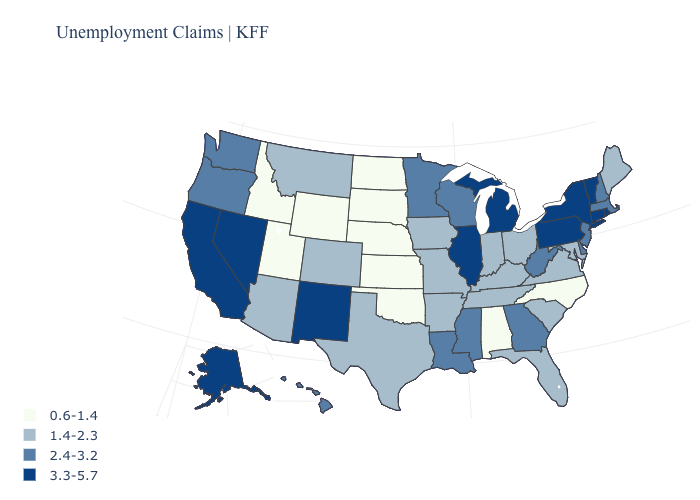What is the lowest value in the West?
Answer briefly. 0.6-1.4. Is the legend a continuous bar?
Answer briefly. No. Does Delaware have the highest value in the South?
Give a very brief answer. Yes. Name the states that have a value in the range 2.4-3.2?
Keep it brief. Delaware, Georgia, Hawaii, Louisiana, Massachusetts, Minnesota, Mississippi, New Hampshire, New Jersey, Oregon, Washington, West Virginia, Wisconsin. Name the states that have a value in the range 3.3-5.7?
Give a very brief answer. Alaska, California, Connecticut, Illinois, Michigan, Nevada, New Mexico, New York, Pennsylvania, Rhode Island, Vermont. Name the states that have a value in the range 1.4-2.3?
Be succinct. Arizona, Arkansas, Colorado, Florida, Indiana, Iowa, Kentucky, Maine, Maryland, Missouri, Montana, Ohio, South Carolina, Tennessee, Texas, Virginia. How many symbols are there in the legend?
Give a very brief answer. 4. What is the value of Washington?
Concise answer only. 2.4-3.2. Name the states that have a value in the range 2.4-3.2?
Give a very brief answer. Delaware, Georgia, Hawaii, Louisiana, Massachusetts, Minnesota, Mississippi, New Hampshire, New Jersey, Oregon, Washington, West Virginia, Wisconsin. Name the states that have a value in the range 3.3-5.7?
Write a very short answer. Alaska, California, Connecticut, Illinois, Michigan, Nevada, New Mexico, New York, Pennsylvania, Rhode Island, Vermont. Is the legend a continuous bar?
Write a very short answer. No. What is the lowest value in states that border New Mexico?
Quick response, please. 0.6-1.4. Among the states that border Nevada , which have the highest value?
Short answer required. California. Name the states that have a value in the range 3.3-5.7?
Write a very short answer. Alaska, California, Connecticut, Illinois, Michigan, Nevada, New Mexico, New York, Pennsylvania, Rhode Island, Vermont. Does Washington have a higher value than Montana?
Answer briefly. Yes. 